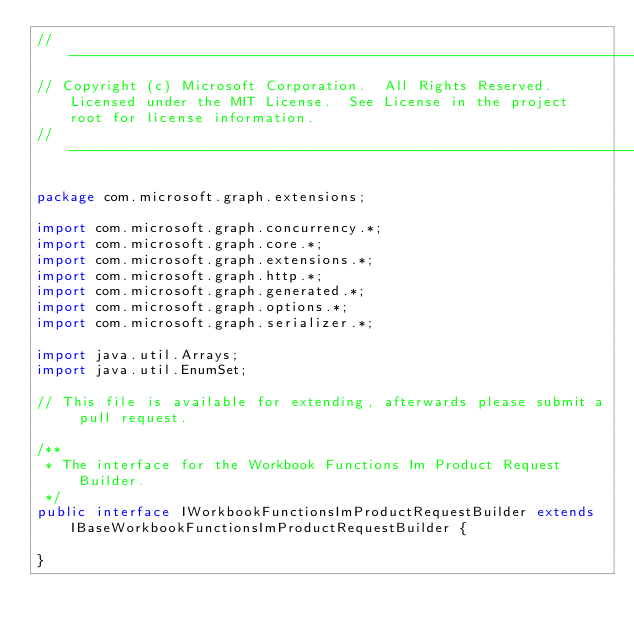Convert code to text. <code><loc_0><loc_0><loc_500><loc_500><_Java_>// ------------------------------------------------------------------------------
// Copyright (c) Microsoft Corporation.  All Rights Reserved.  Licensed under the MIT License.  See License in the project root for license information.
// ------------------------------------------------------------------------------

package com.microsoft.graph.extensions;

import com.microsoft.graph.concurrency.*;
import com.microsoft.graph.core.*;
import com.microsoft.graph.extensions.*;
import com.microsoft.graph.http.*;
import com.microsoft.graph.generated.*;
import com.microsoft.graph.options.*;
import com.microsoft.graph.serializer.*;

import java.util.Arrays;
import java.util.EnumSet;

// This file is available for extending, afterwards please submit a pull request.

/**
 * The interface for the Workbook Functions Im Product Request Builder.
 */
public interface IWorkbookFunctionsImProductRequestBuilder extends IBaseWorkbookFunctionsImProductRequestBuilder {

}
</code> 